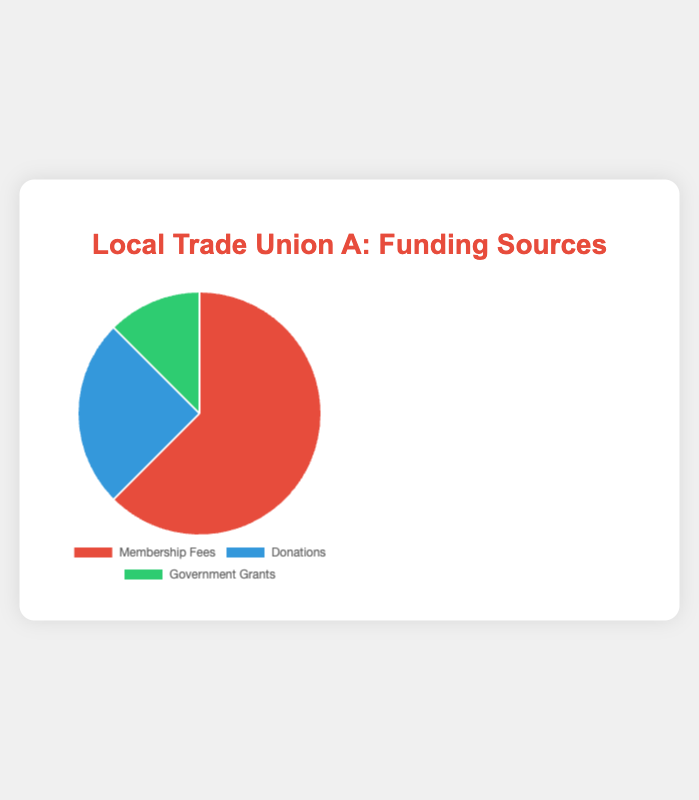Which funding source provides the largest share of the union's funding? The figure shows that Membership Fees have the largest share of the funding, as indicated by the largest section of the pie chart.
Answer: Membership Fees What percentage of the union’s funding comes from Government Grants? To find the percentage of funding from Government Grants, divide the amount from Government Grants ($10,000) by the total funding amount ($80,000) and multiply by 100%. So, (10,000 / 80,000) * 100 = 12.5%.
Answer: 12.5% How much more funding comes from Membership Fees compared to Donations? The amount from Membership Fees is $50,000, and from Donations is $20,000. Subtract the amount of Donations from Membership Fees: $50,000 - $20,000 = $30,000.
Answer: $30,000 If the total funding is increased by 50%, what will be the new total funding amount? First, find the current total funding, which is $80,000. Increasing it by 50%, calculate: 80,000 * 1.50 = $120,000.
Answer: $120,000 Is the amount received from Donations more than half the amount from Membership Fees? The amount from Membership Fees is $50,000. Half of that is $25,000. Since Donations amount to $20,000, which is less than $25,000, it is not more than half.
Answer: No What is the difference between the sum of the funds from Membership Fees and Donations compared to Government Grants? Sum the amounts from Membership Fees and Donations: $50,000 + $20,000 = $70,000. Then find the difference with Government Grants: $70,000 - $10,000 = $60,000.
Answer: $60,000 What portion of the pie chart is represented by Donations, in terms of color? The chart represents Donations in blue, as indicated by the pie section with Donations label colored in blue.
Answer: Blue 